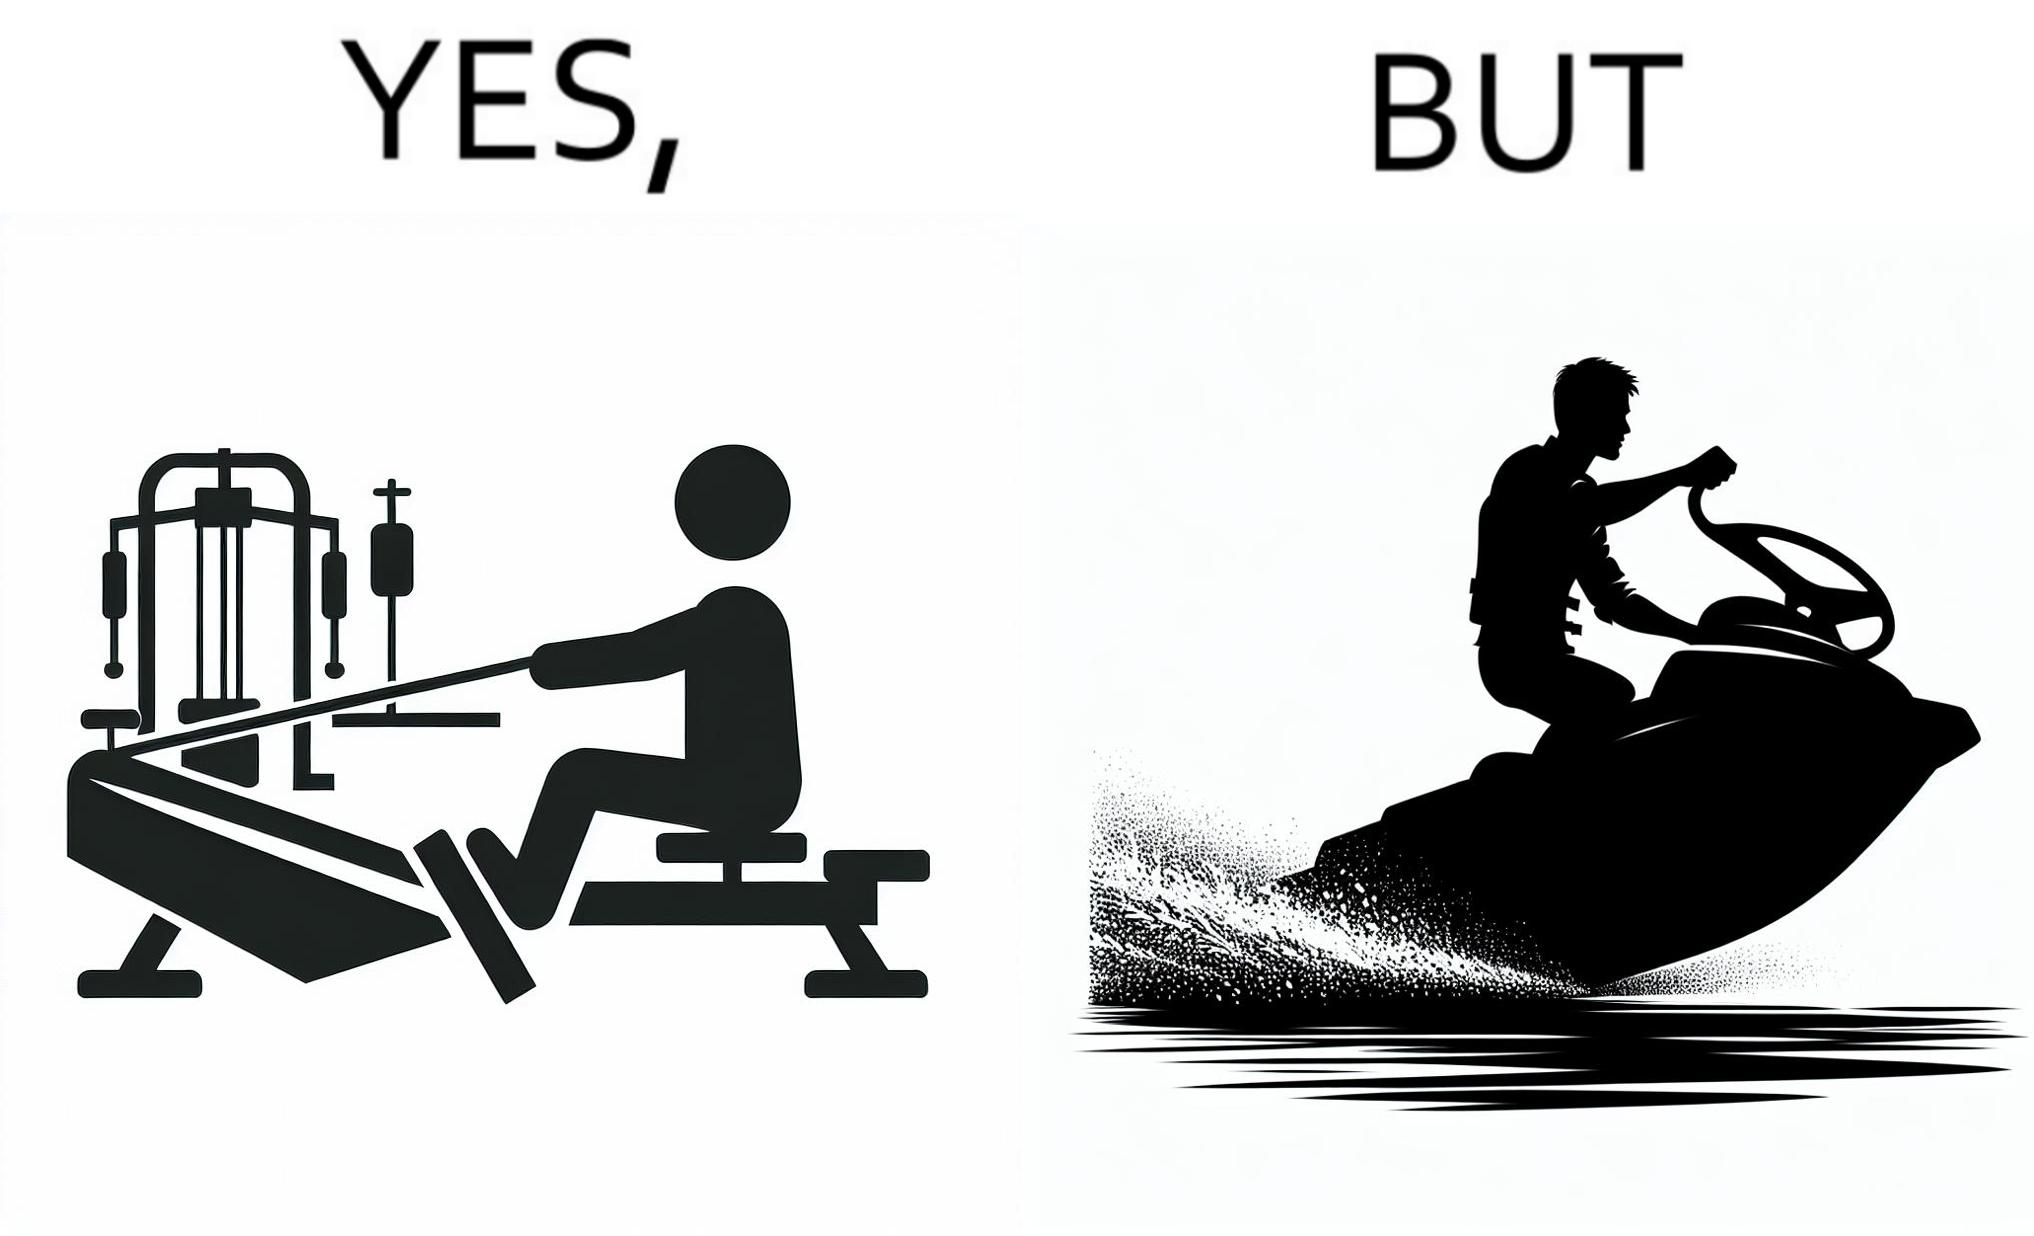Describe the satirical element in this image. The image is ironic, because people often use rowing machine at the gym don't prefer rowing when it comes to boats 